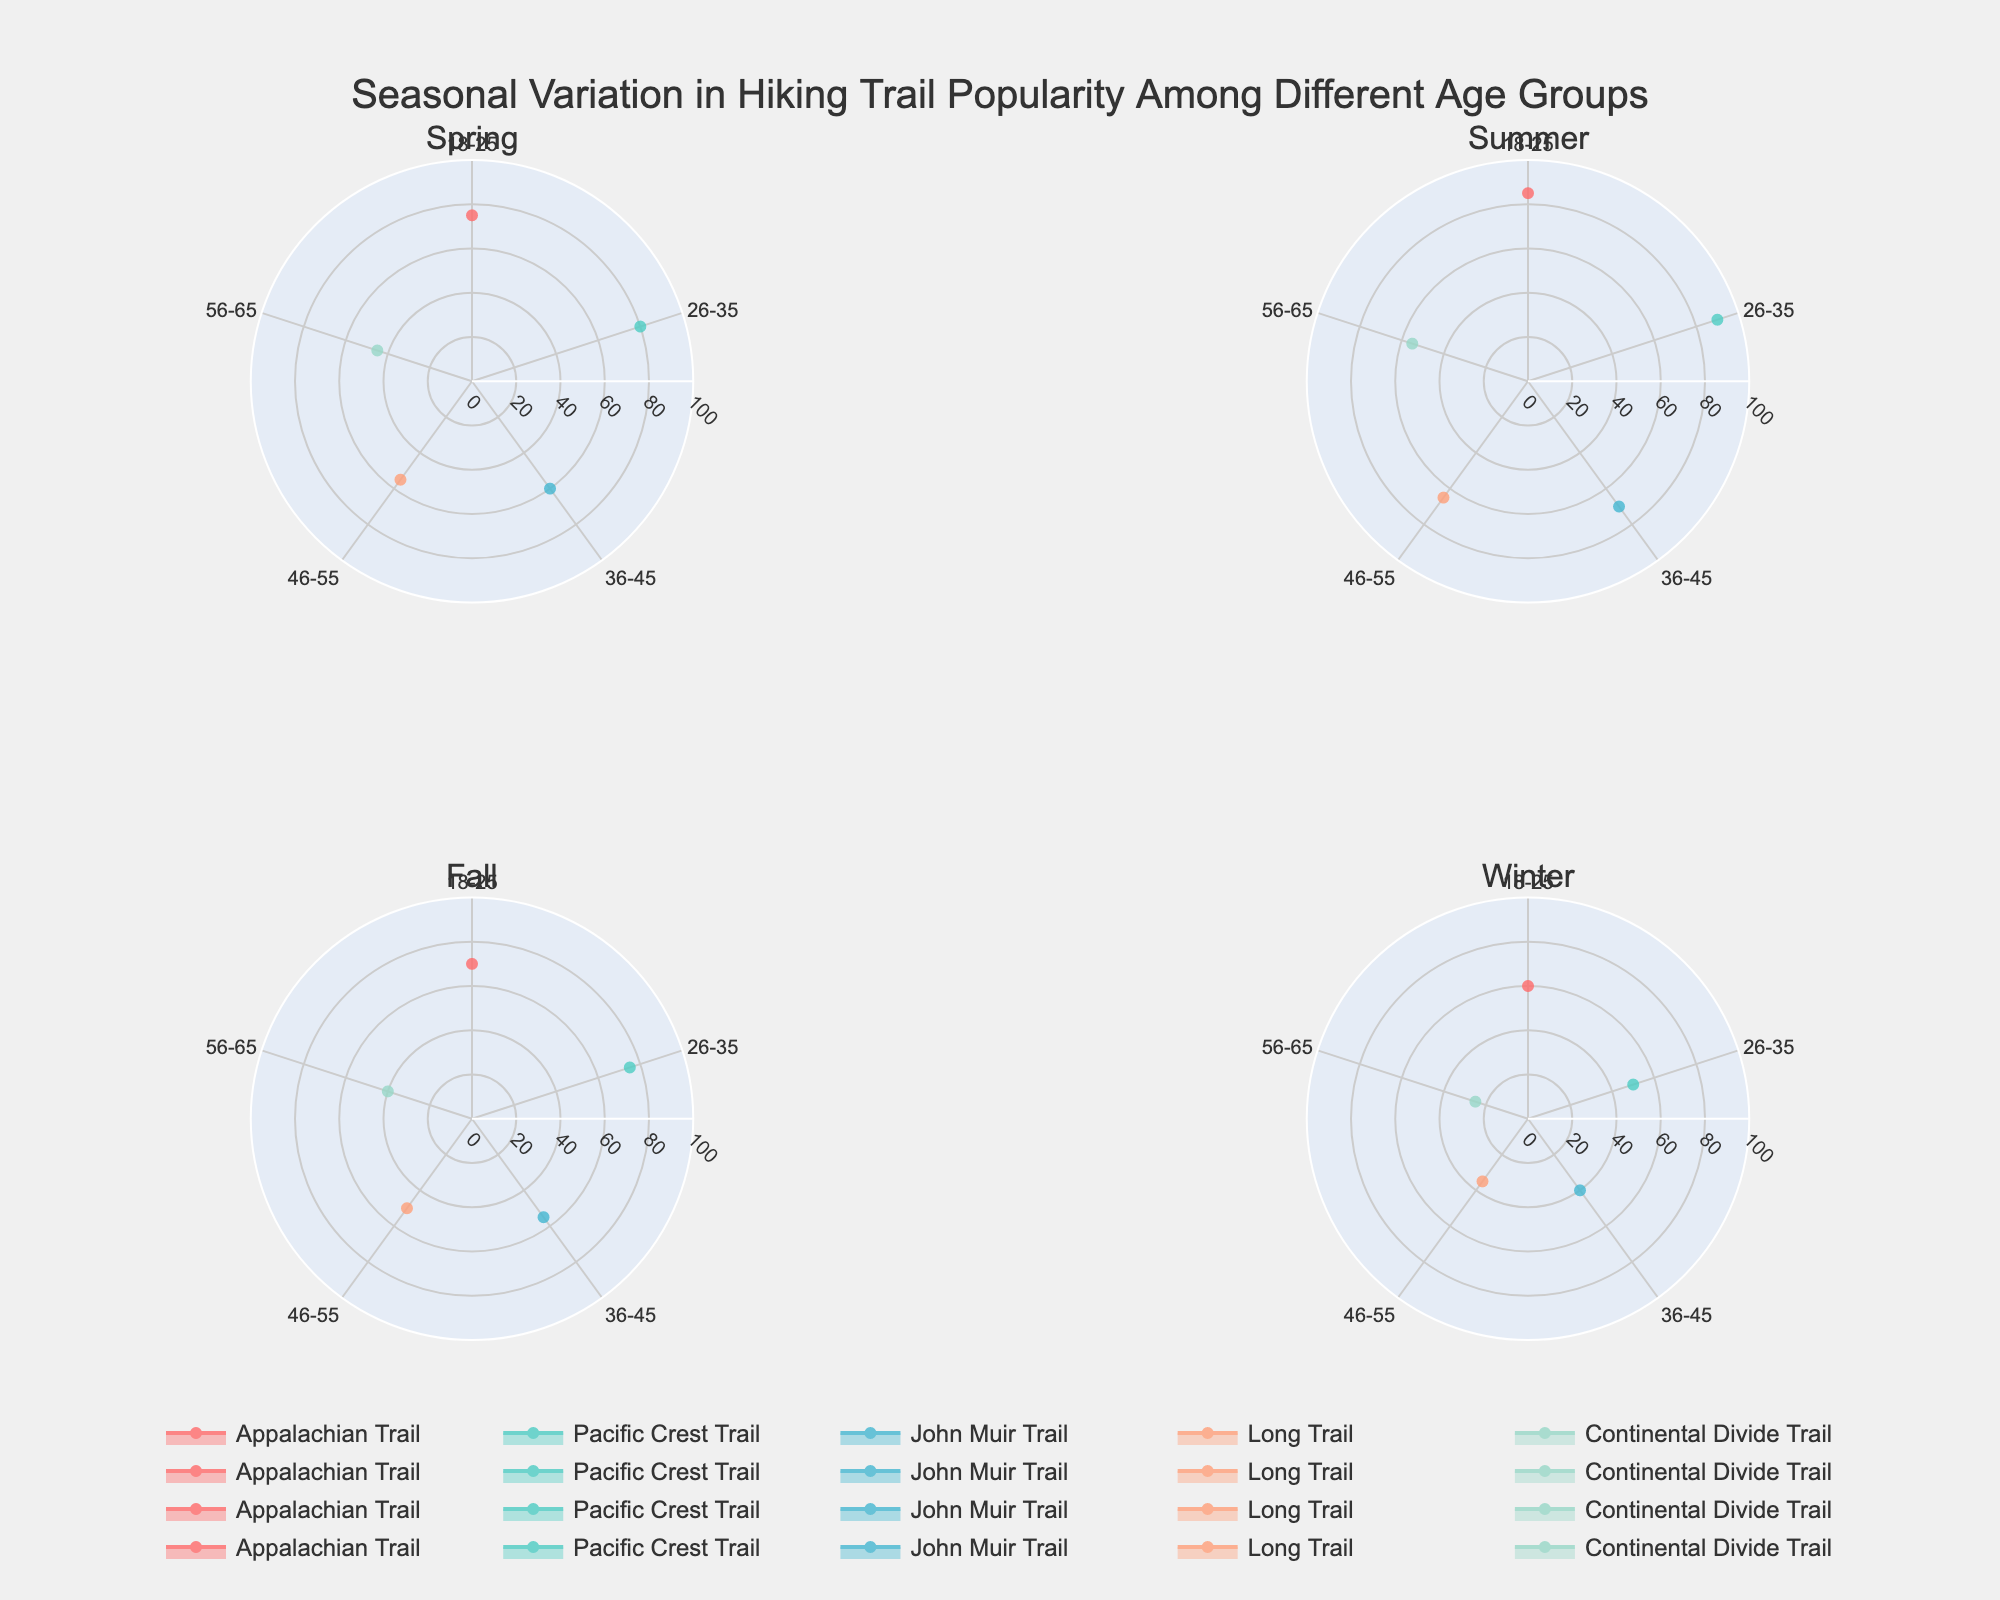What is the title of the figure? The title is clearly visible at the center top of the figure, indicating the theme of the seasonal variation and trail popularity among age groups.
Answer: Seasonal Variation in Hiking Trail Popularity Among Different Age Groups Which trail is the most popular among the 18-25 age group in Spring? By examining the "Spring" subplot, the Appalachian Trail shows the highest radial distance (popularity score) among the 18-25 age group.
Answer: Appalachian Trail Which season has the least popularity for the 56-65 age group on the John Muir Trail? The Winter subplot shows the shortest radial distance (popularity score) for the John Muir Trail among the 56-65 age group, indicating the least popularity.
Answer: Winter Compare the popularity of the Long Trail in the 46-55 age group between Summer and Winter. Which season is it more popular in? Check the radial distance in both the Summer and Winter subplots for the Long Trail in the 46-55 age group. Summer has a larger radial distance compared to Winter.
Answer: Summer Which trail consistently shows "Easier" difficulty rating across all seasons for the 56-65 age group? By looking at the labels in the polar subplots for all seasons, the Continental Divide Trail always appears with a low radial distance and is consistent with an 'Easier' rating annotated in the data.
Answer: Continental Divide Trail What trail shows the highest popularity in the Summer for the 26-35 age group? By examining the "Summer" subplot, the Pacific Crest Trail has the highest radial distance in the 26-35 age group.
Answer: Pacific Crest Trail During Fall, which trail has a popularity rating closest to 50 among the 46-55 age group? In the Fall subplot, look for the trail with a radial distance close to 50 for the 46-55 age group. The Long Trail has a value closest to 50.
Answer: Long Trail On the John Muir Trail, which age group shows the most variation in popularity across seasons? By comparing the radial distances for the John Muir Trail in each subplot, the 36-45 age group shows the most variation, changing significantly from season to season.
Answer: 36-45 Is there any season where "Easier" trails for the 56-65 age group show a substantial reduction in popularity compared to other seasons? By comparing the radial distances for the Continental Divide Trail (an "Easier" trail) in the 56-65 age group across all seasons, Winter shows a substantial reduction in popularity.
Answer: Winter 